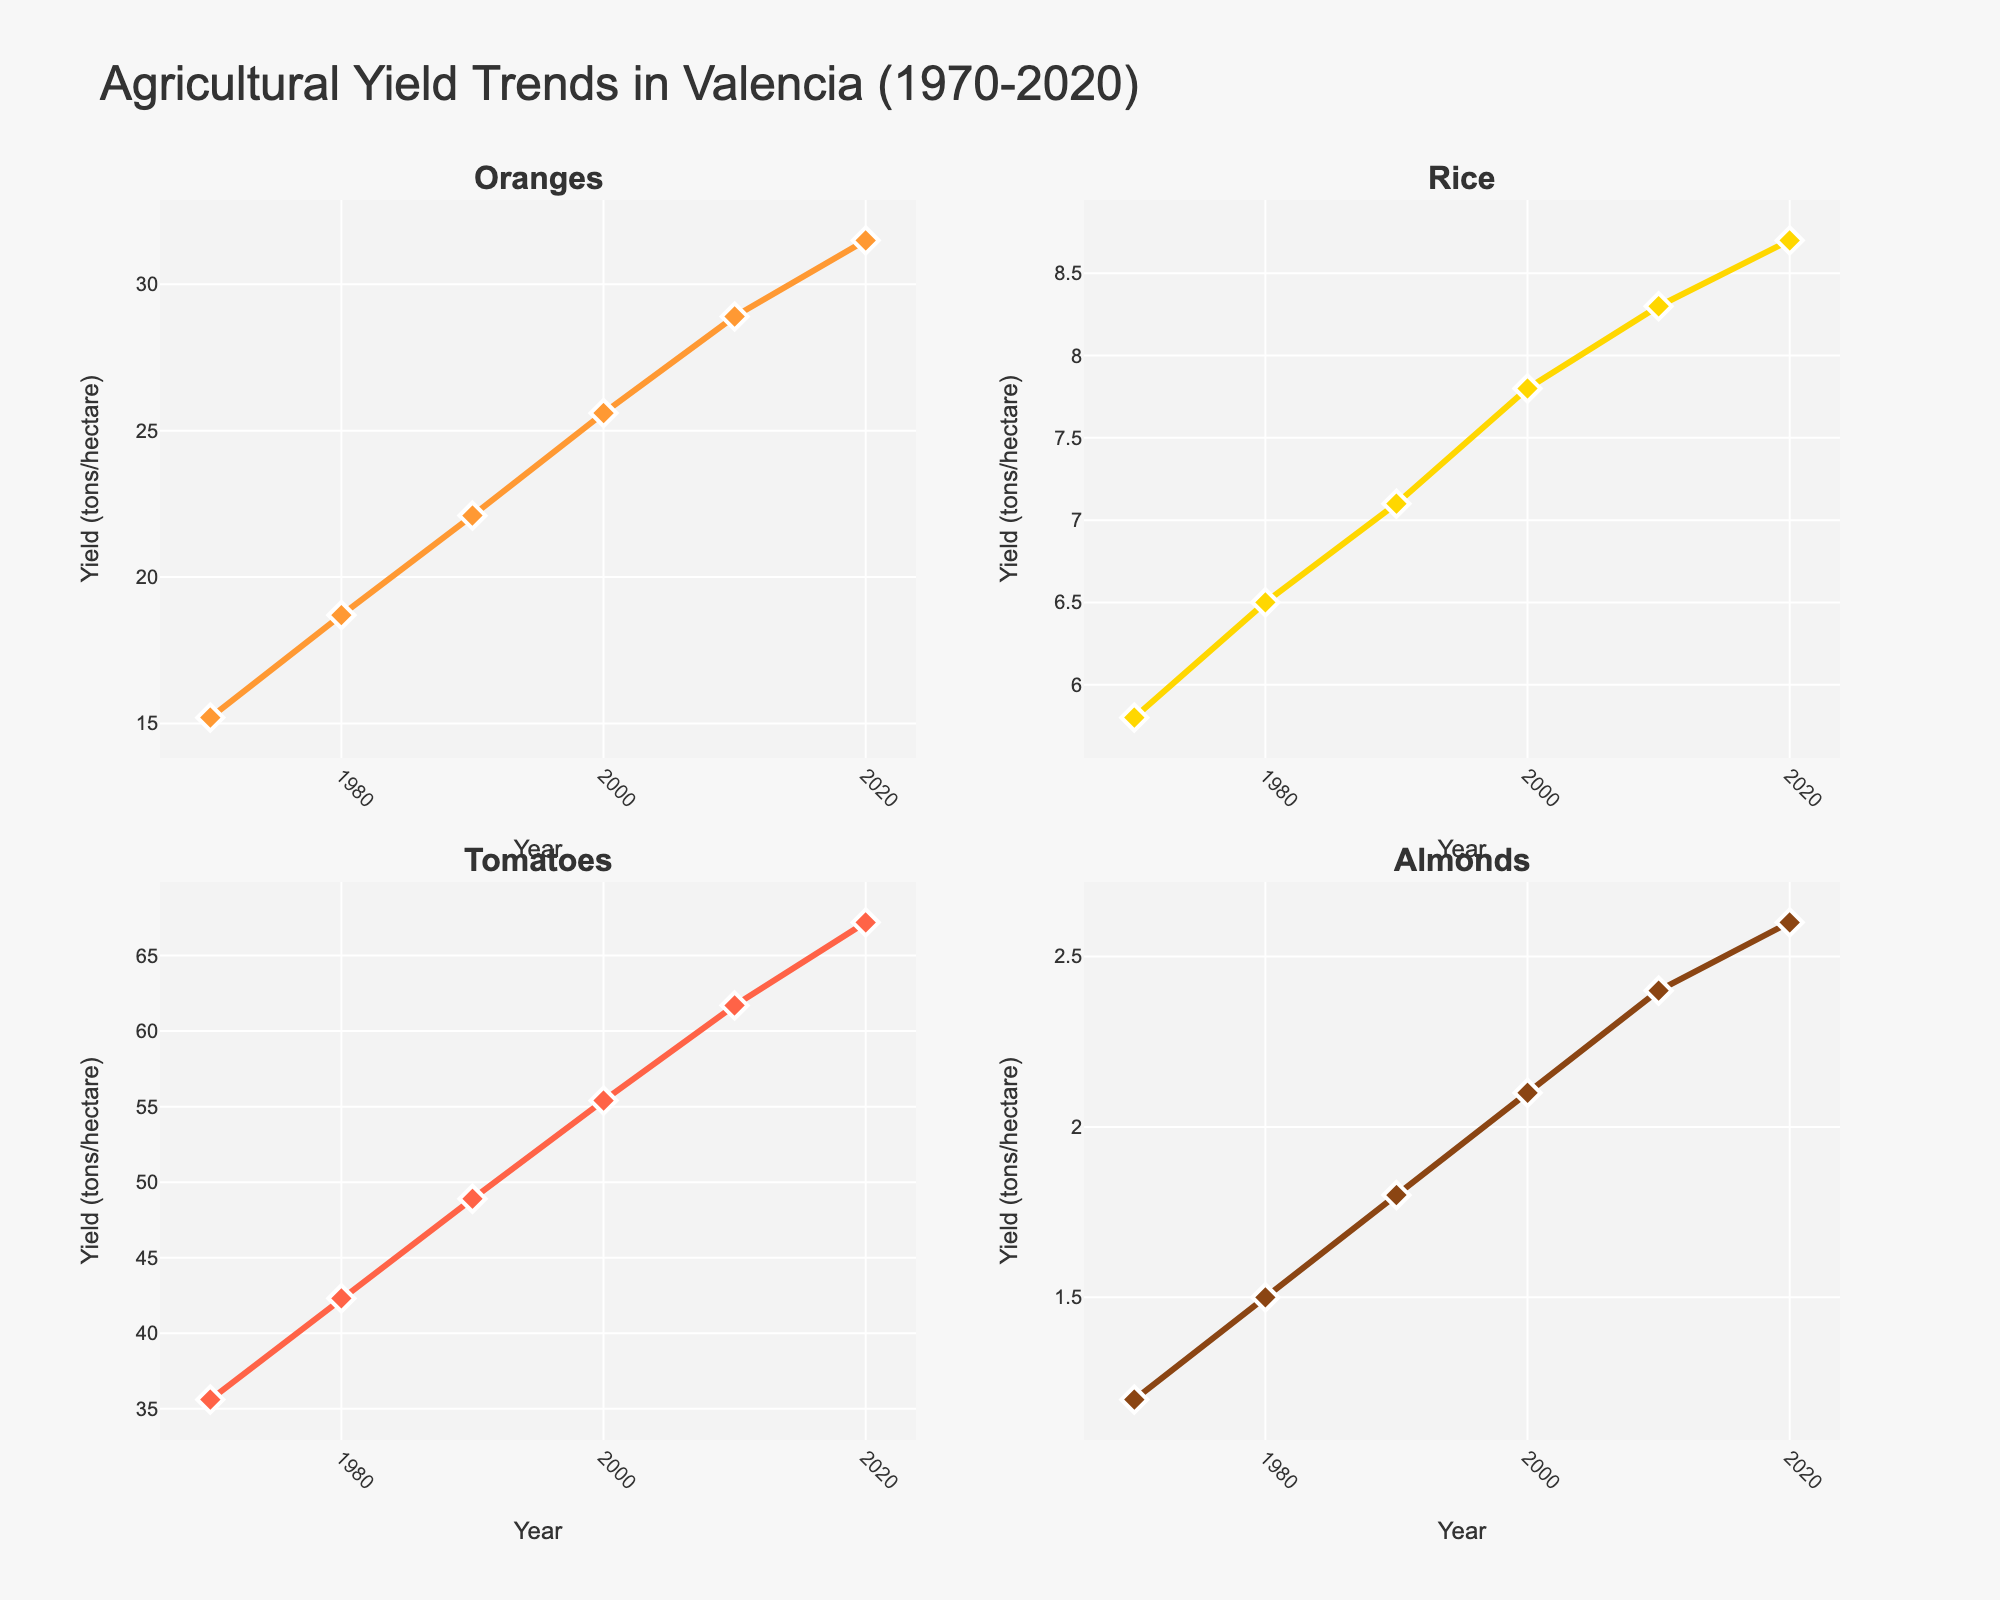What year had the highest yield for Almonds? The Almonds yield is highest in the last data point, which corresponds to the year 2020 and shows a yield of 2.6 tons/hectare.
Answer: 2020 What is the range of yields for Oranges? The range is calculated as the difference between the maximum and minimum values. For Oranges, the yield ranges from 15.2 tons/hectare in 1970 to 31.5 tons/hectare in 2020. So, 31.5 - 15.2 = 16.3 tons/hectare.
Answer: 16.3 tons/hectare How many crops had their highest yield recorded in 2010? By inspecting each subplot, we observe that none of the crops have 2010 as their highest yield. Therefore, the answer is zero.
Answer: 0 Which crop showed the most increase in yield between 2000 and 2020? Calculate the increase for each crop: Oranges (31.5 - 25.6 = 5.9), Rice (8.7 - 7.8 = 0.9), Tomatoes (67.2 - 55.4 = 11.8), Almonds (2.6 - 2.1 = 0.5). Tomatoes had the highest increase of 11.8 tons/hectare.
Answer: Tomatoes Is the annual yield for Rice ever lower than the yield for Almonds for the given years? By visually comparing the yields of Rice and Almonds across all years, Rice yield is always higher than Almonds yield.
Answer: No What was the average yield for Tomatoes over the years? Sum the yield values for Tomatoes and divide by the number of data points: (35.6 + 42.3 + 48.9 + 55.4 + 61.7 + 67.2) / 6 = 51.85 tons/hectare.
Answer: 51.85 tons/hectare What is the linear trend of the yield for Oranges over the years? The yield for Oranges increased steadily over the years. Starting from 15.2 tons/hectare in 1970 to 31.5 tons/hectare in 2020.
Answer: Increasing trend Compare the yield patterns for Oranges and Rice between 1970 and 2020. Both Oranges and Rice show an increasing trend. However, the yield for Oranges shows a more significant increase (from 15.2 to 31.5) compared to Rice (from 5.8 to 8.7).
Answer: Both increased, but Oranges increased more Between 1980 and 2000, did any crop have a yield decrease? Checking each crop's subplot, we see no crop shows a decrease between 1980 and 2000. All crops increased in yield during this period.
Answer: No 